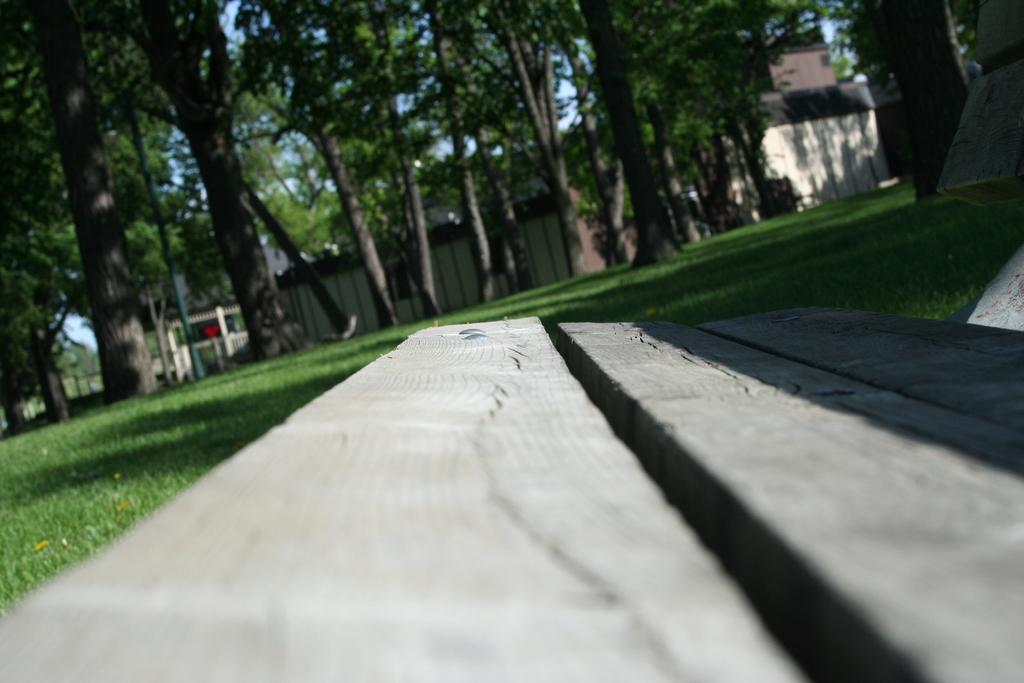What type of seating is visible in the image? There is a bench in the image. What can be seen in the distance behind the bench? There are trees and houses in the background of the image. What is visible in the sky in the image? The sky is clear and visible in the background of the image. Reasoning: Let's think step by following the guidelines to produce the conversation. We start by identifying the main subject in the image, which is the bench. Then, we expand the conversation to include other elements visible in the image, such as the trees, houses, and sky. Each question is designed to elicit a specific detail about the image that is known from the provided facts. Absurd Question/Answer: Is there a stage present in the image? No, there is no stage visible in the image. 